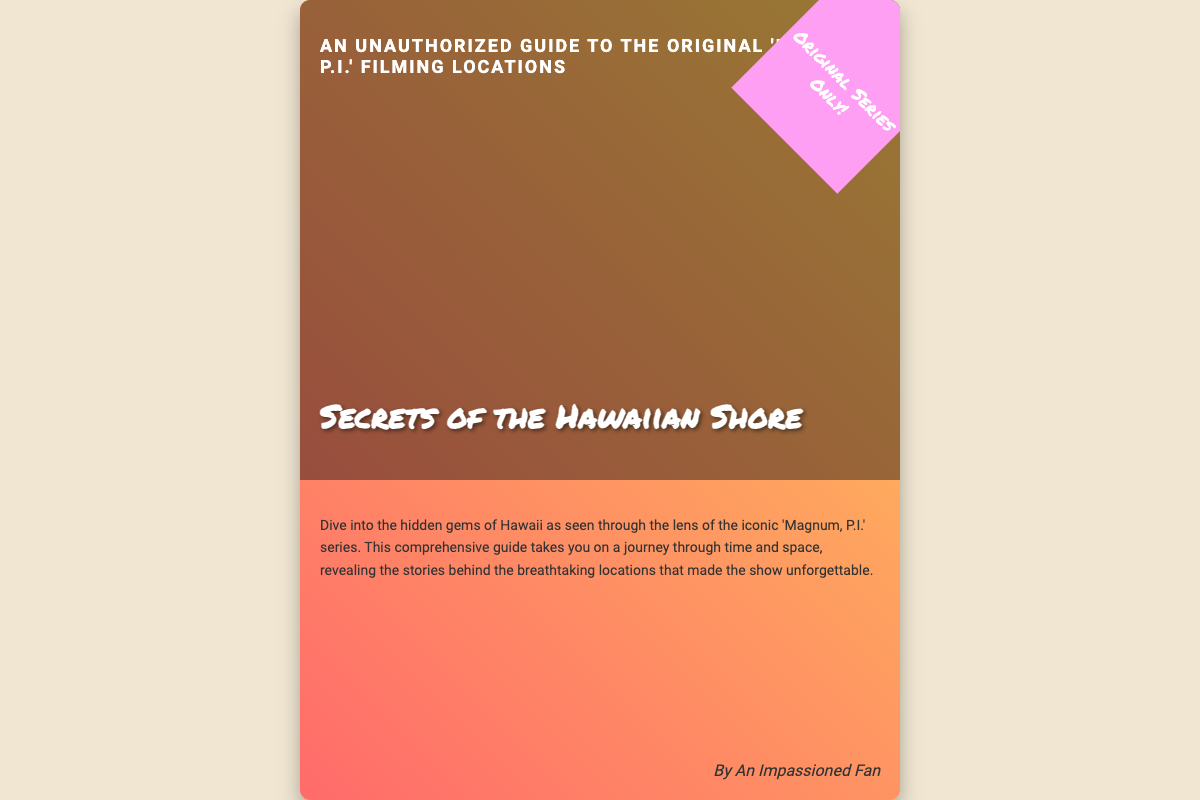What is the title of the book? The title is prominently displayed on the cover and reads "Secrets of the Hawaiian Shore."
Answer: Secrets of the Hawaiian Shore What subtitle is associated with the book? The subtitle provides additional context and is found below the title, reading "An Unauthorized Guide to the Original 'Magnum, P.I.' Filming Locations."
Answer: An Unauthorized Guide to the Original 'Magnum, P.I.' Filming Locations Who is the author of the book? The author’s name is indicated at the bottom of the cover, stating "By An Impassioned Fan."
Answer: An Impassioned Fan What type of locations does the book focus on? The description mentions the book explores locations related to the 'Magnum, P.I.' series specifically in Hawaii.
Answer: Hawaii What color scheme is prominent on the book cover? The background utilizes a gradient effect which combines pink and yellow tones, enhancing the tropical feel.
Answer: Pink and yellow 